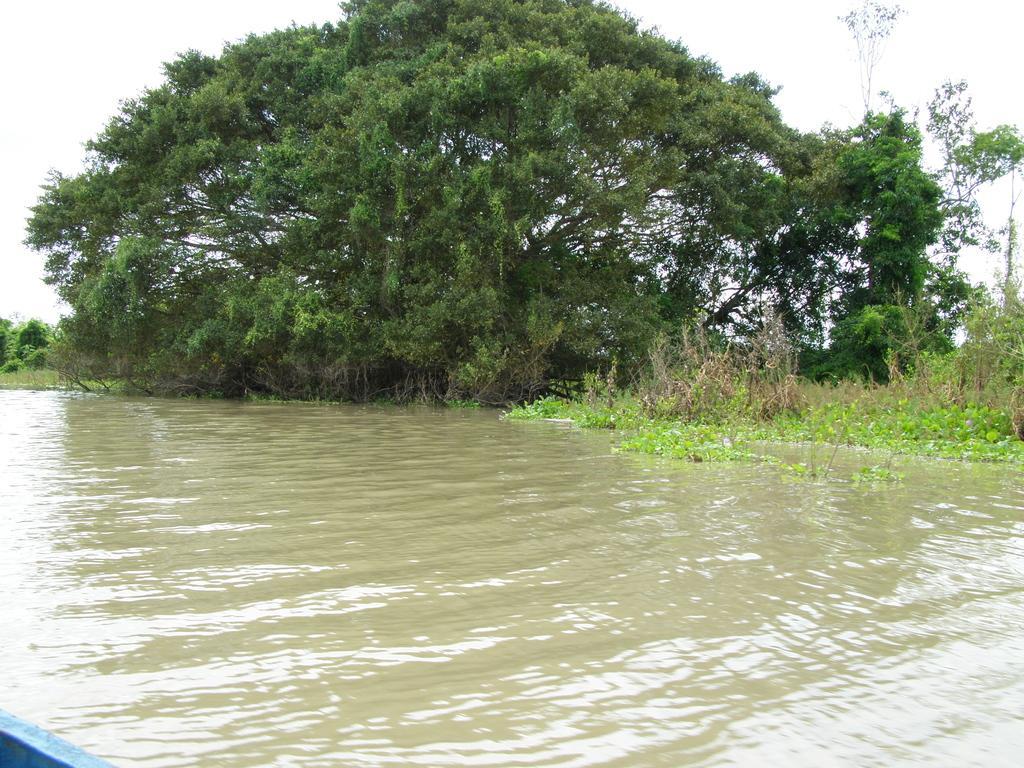How would you summarize this image in a sentence or two? In this image I can see water in the front. In the background I can see grass, number of trees and the sky. On the bottom left corner of the image I can see a blue colour thing. 